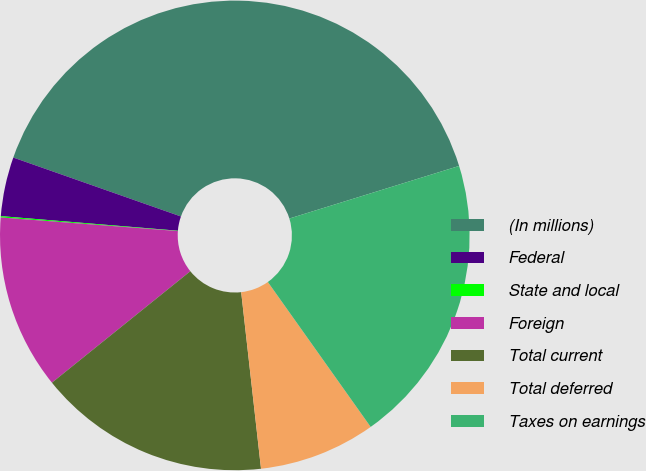<chart> <loc_0><loc_0><loc_500><loc_500><pie_chart><fcel>(In millions)<fcel>Federal<fcel>State and local<fcel>Foreign<fcel>Total current<fcel>Total deferred<fcel>Taxes on earnings<nl><fcel>39.84%<fcel>4.07%<fcel>0.09%<fcel>12.01%<fcel>15.99%<fcel>8.04%<fcel>19.96%<nl></chart> 